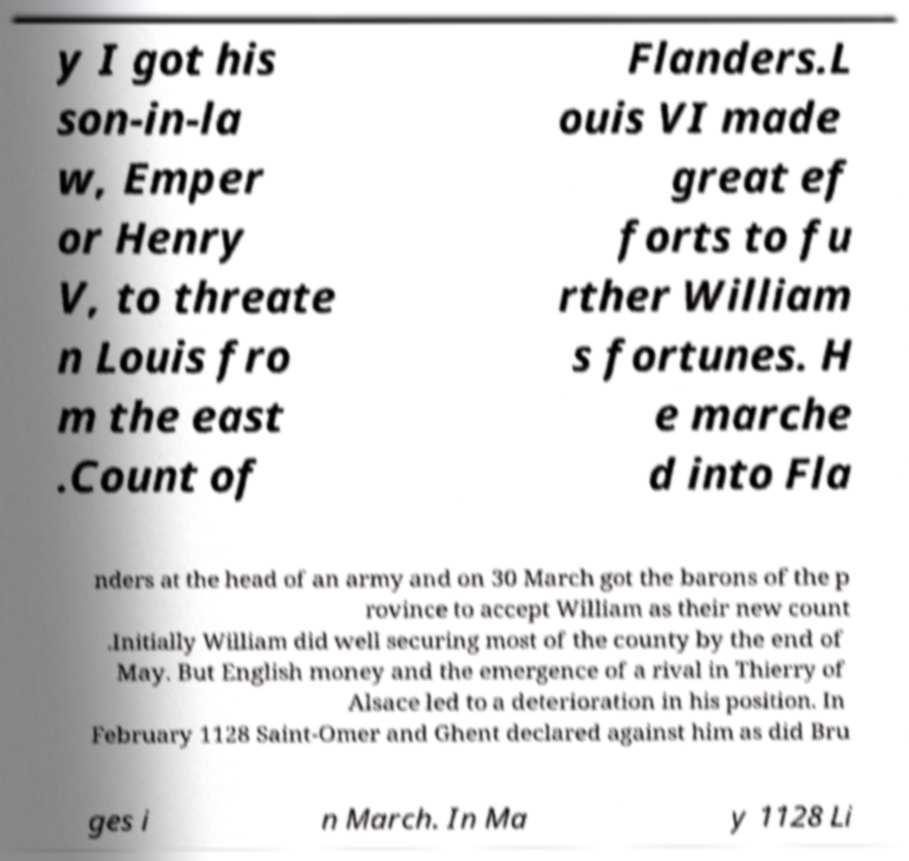Please read and relay the text visible in this image. What does it say? y I got his son-in-la w, Emper or Henry V, to threate n Louis fro m the east .Count of Flanders.L ouis VI made great ef forts to fu rther William s fortunes. H e marche d into Fla nders at the head of an army and on 30 March got the barons of the p rovince to accept William as their new count .Initially William did well securing most of the county by the end of May. But English money and the emergence of a rival in Thierry of Alsace led to a deterioration in his position. In February 1128 Saint-Omer and Ghent declared against him as did Bru ges i n March. In Ma y 1128 Li 